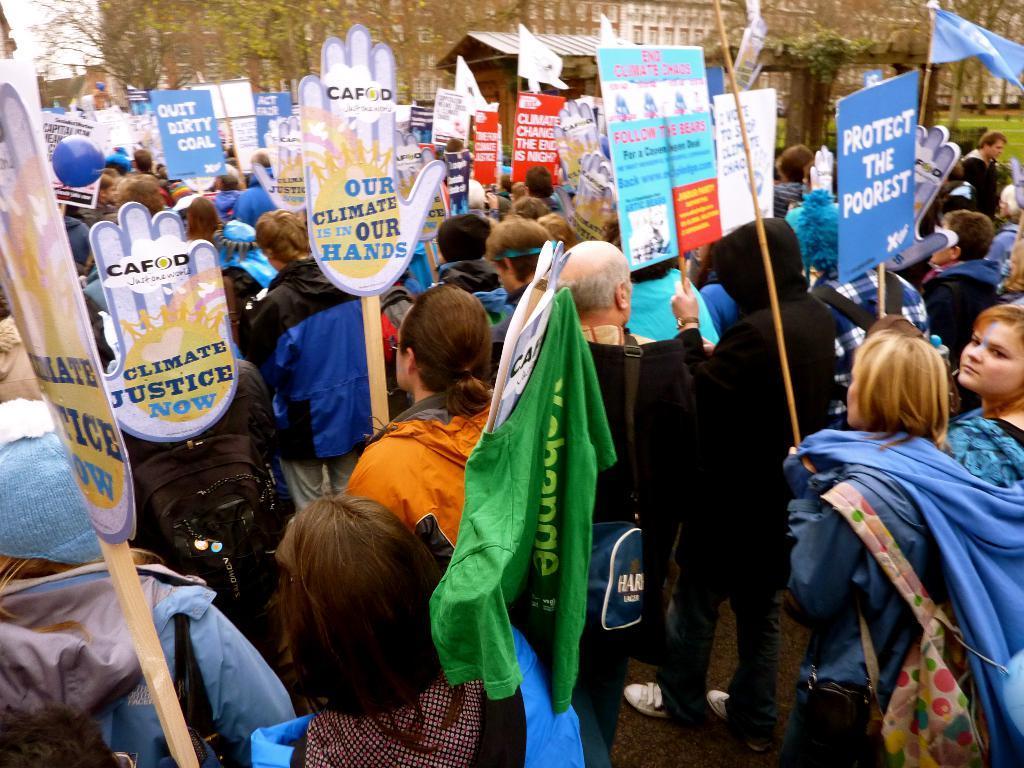In one or two sentences, can you explain what this image depicts? In this image we can see a group of people standing on the ground holding the boards in their hands. One person is carrying a bag. In the background, we can see building, group of trees and the sky. 